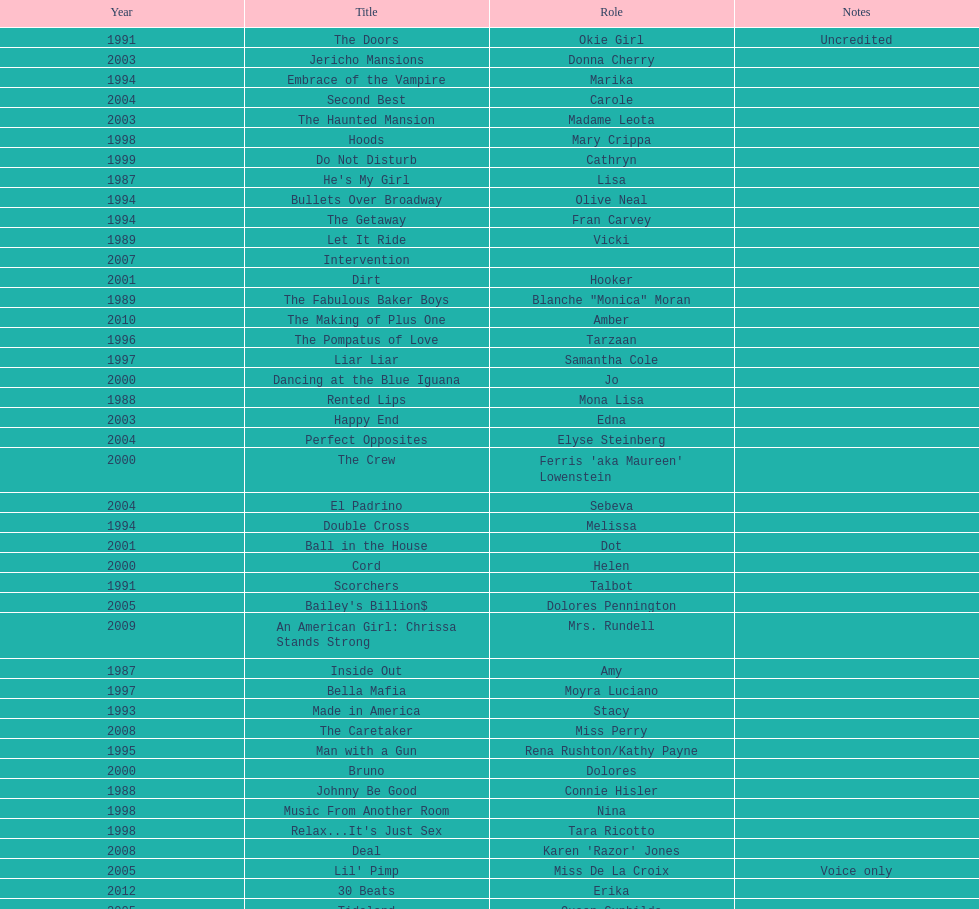Which movie was also a film debut? No Small Affair. 